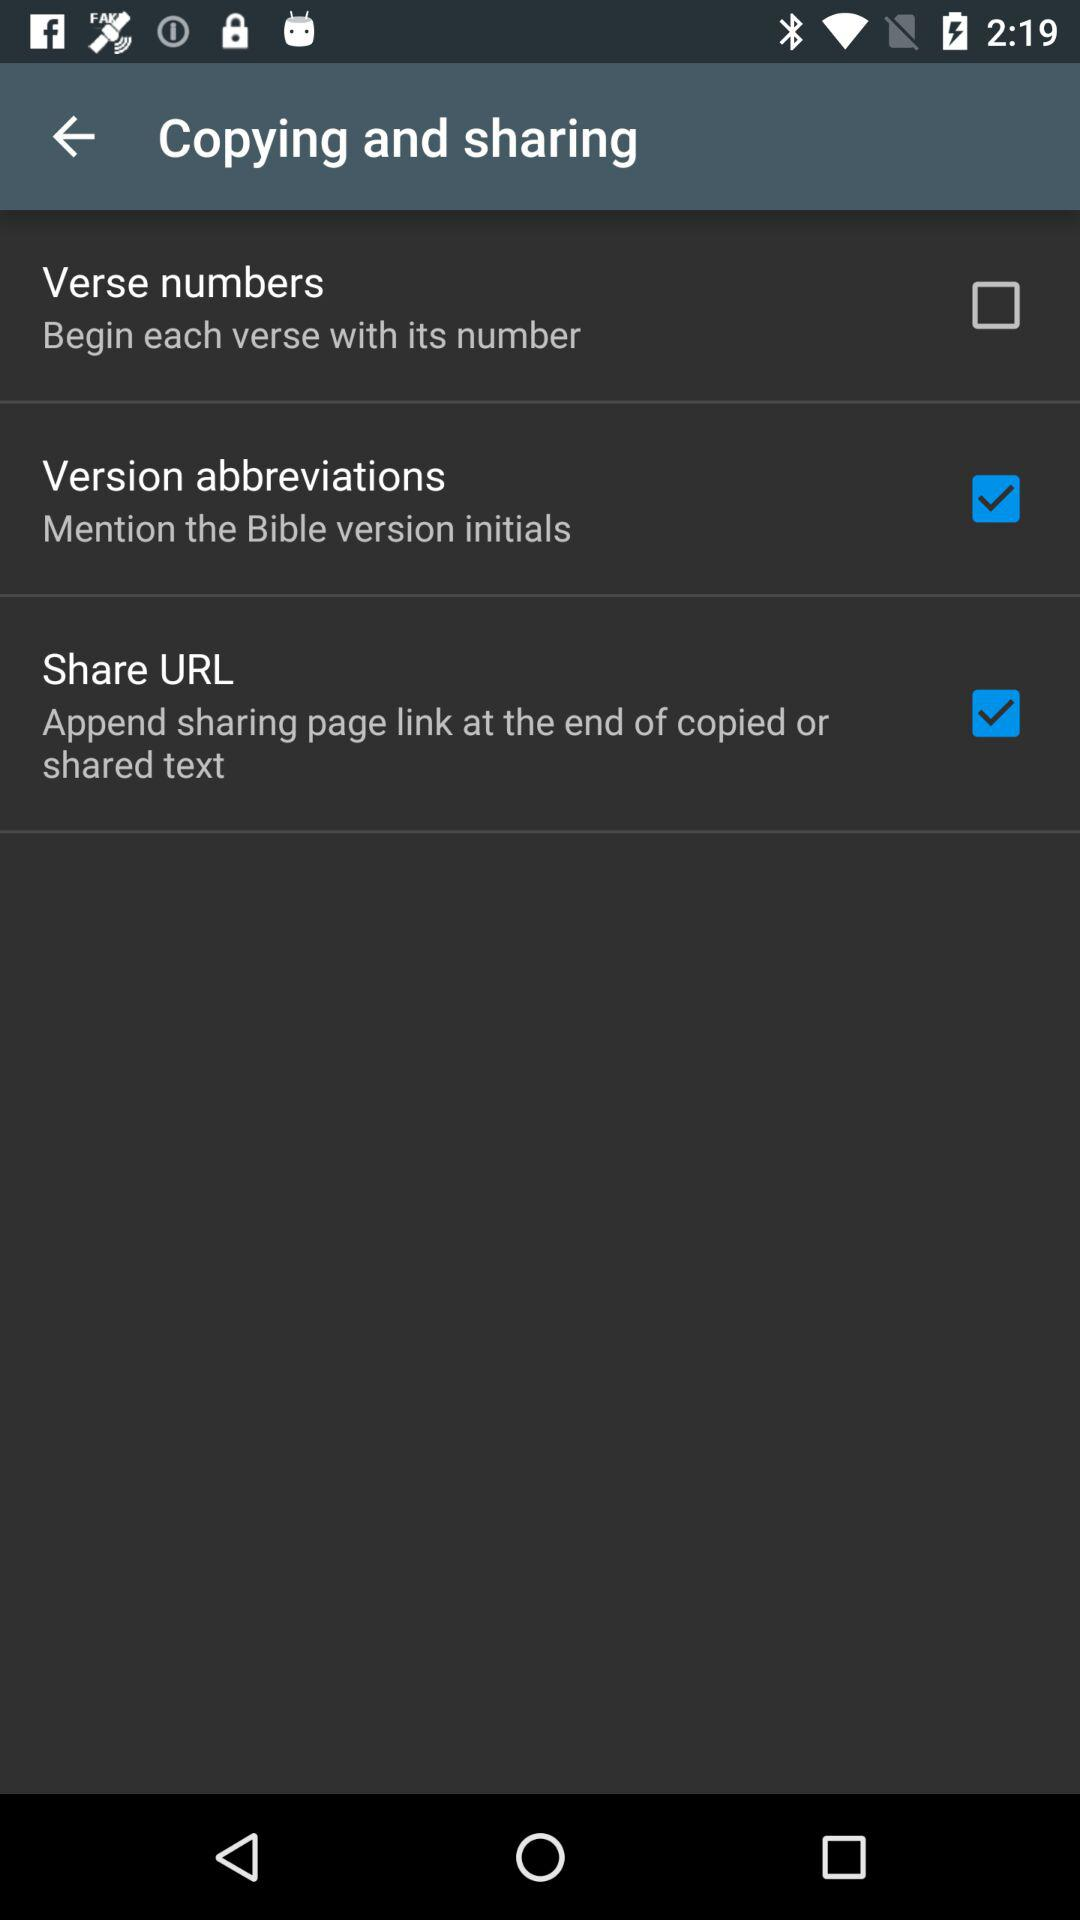When was the application copyrighted?
When the provided information is insufficient, respond with <no answer>. <no answer> 